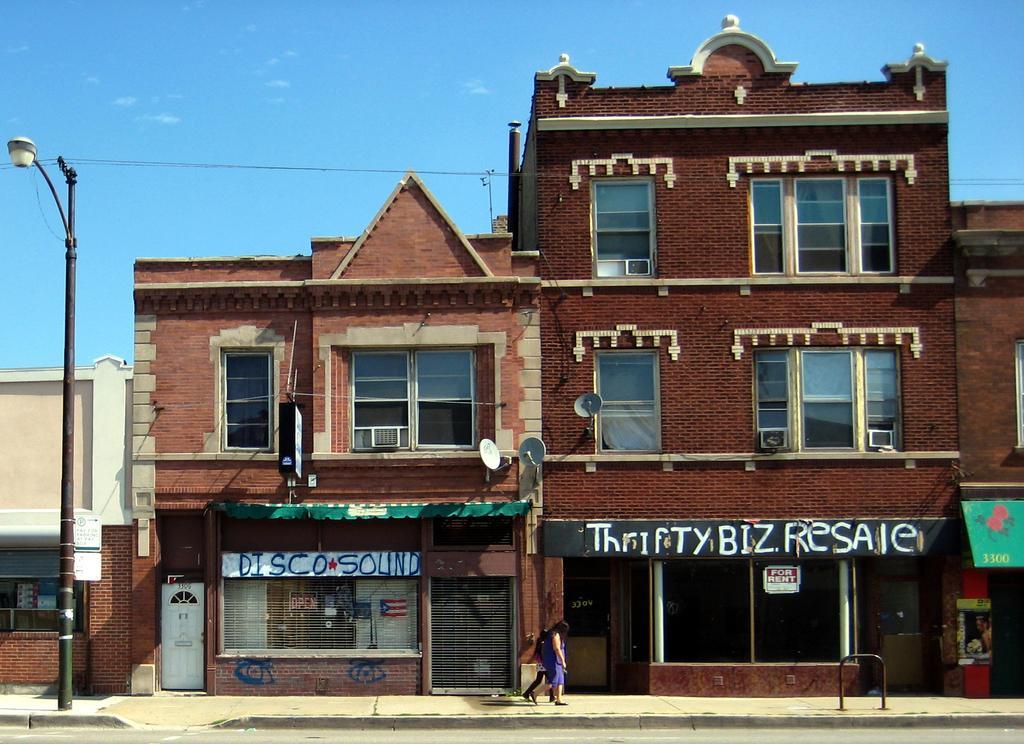Could you give a brief overview of what you see in this image? In the middle of the image two persons are walking. Beside them there are some buildings and poles. At the top of the image there are some clouds in the sky. 